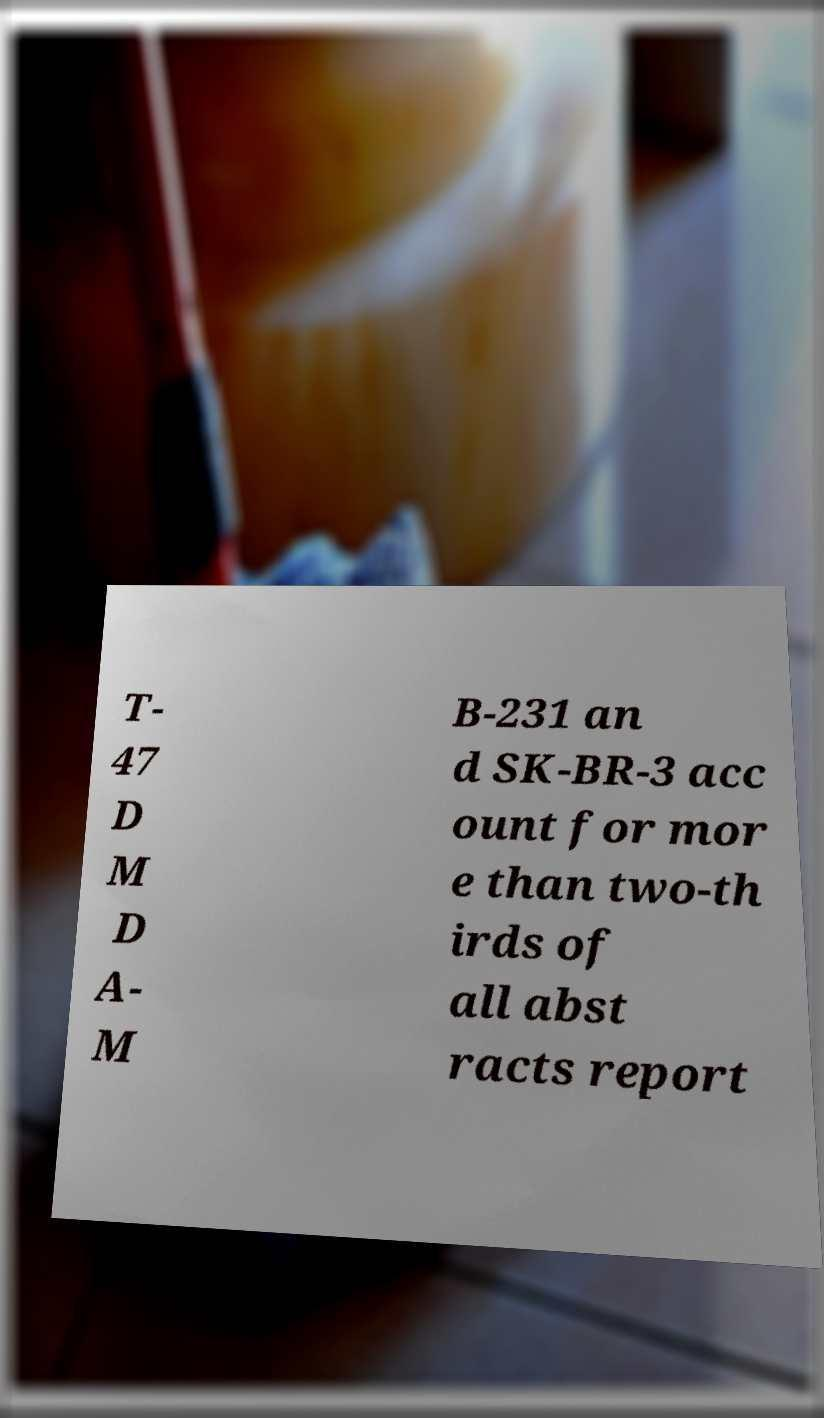What messages or text are displayed in this image? I need them in a readable, typed format. T- 47 D M D A- M B-231 an d SK-BR-3 acc ount for mor e than two-th irds of all abst racts report 